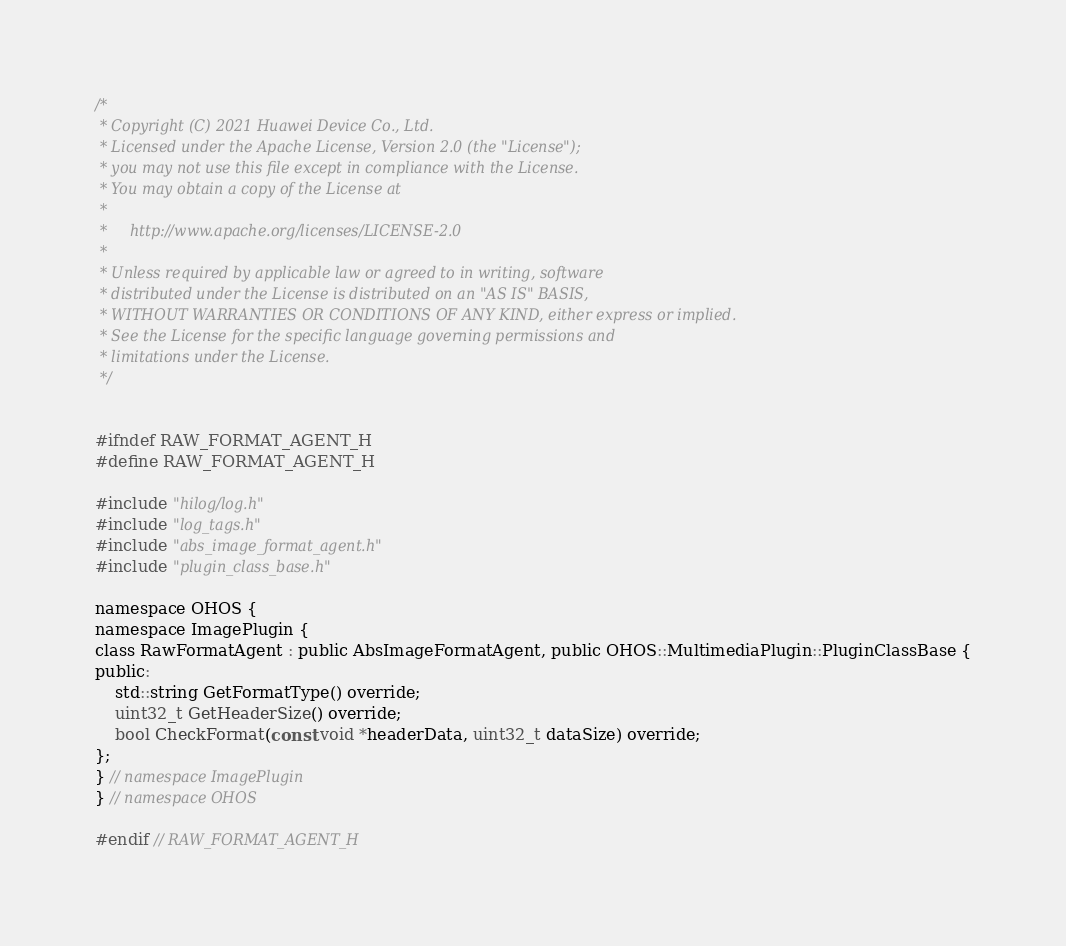<code> <loc_0><loc_0><loc_500><loc_500><_C_>/*
 * Copyright (C) 2021 Huawei Device Co., Ltd.
 * Licensed under the Apache License, Version 2.0 (the "License");
 * you may not use this file except in compliance with the License.
 * You may obtain a copy of the License at
 *
 *     http://www.apache.org/licenses/LICENSE-2.0
 *
 * Unless required by applicable law or agreed to in writing, software
 * distributed under the License is distributed on an "AS IS" BASIS,
 * WITHOUT WARRANTIES OR CONDITIONS OF ANY KIND, either express or implied.
 * See the License for the specific language governing permissions and
 * limitations under the License.
 */


#ifndef RAW_FORMAT_AGENT_H
#define RAW_FORMAT_AGENT_H

#include "hilog/log.h"
#include "log_tags.h"
#include "abs_image_format_agent.h"
#include "plugin_class_base.h"

namespace OHOS {
namespace ImagePlugin {
class RawFormatAgent : public AbsImageFormatAgent, public OHOS::MultimediaPlugin::PluginClassBase {
public:
    std::string GetFormatType() override;
    uint32_t GetHeaderSize() override;
    bool CheckFormat(const void *headerData, uint32_t dataSize) override;
};
} // namespace ImagePlugin
} // namespace OHOS

#endif // RAW_FORMAT_AGENT_H</code> 